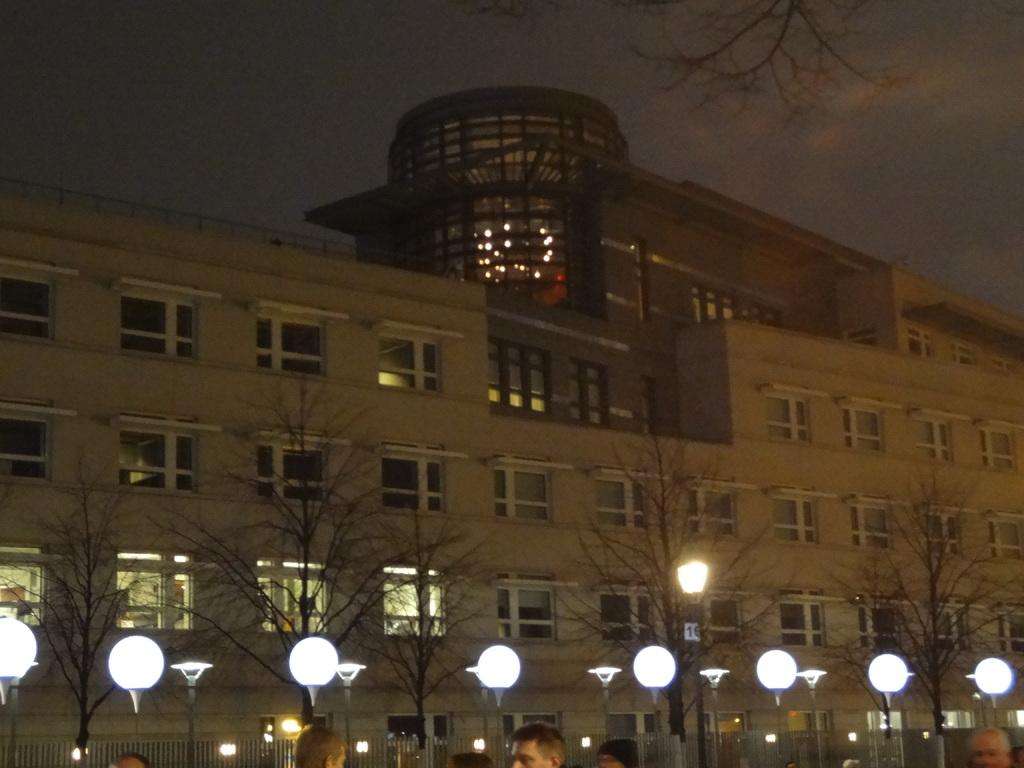What type of structure is in the image? There is a building in the image. What feature of the building is mentioned in the facts? The building has many windows. What type of artificial light source is present in the image? Street lights are present in the image. What type of natural elements are visible in the image? Trees and the sky are visible in the image. What is the condition of the sky in the image? Clouds are present in the sky. What time of day is the image taken? The image was taken at night time. What type of pen is being used to draw on the building in the image? There is no pen or drawing present in the image; it is a photograph of a building with many windows, street lights, trees, and a sky with clouds. 